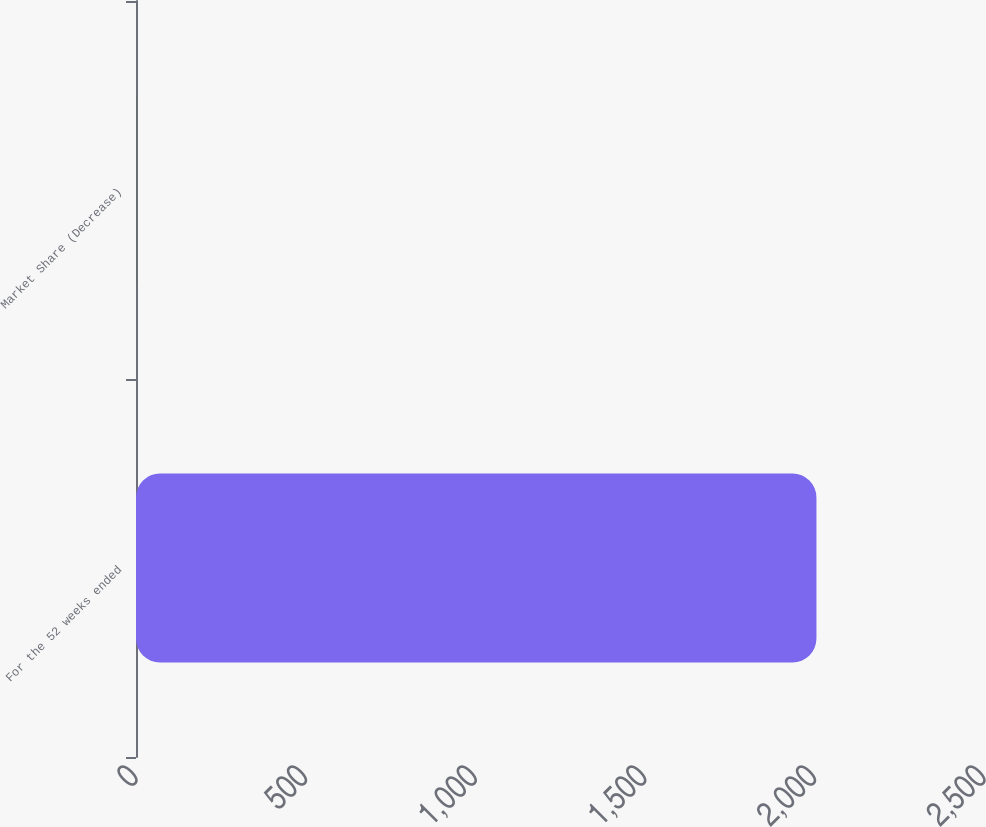Convert chart to OTSL. <chart><loc_0><loc_0><loc_500><loc_500><bar_chart><fcel>For the 52 weeks ended<fcel>Market Share (Decrease)<nl><fcel>2006<fcel>0.2<nl></chart> 